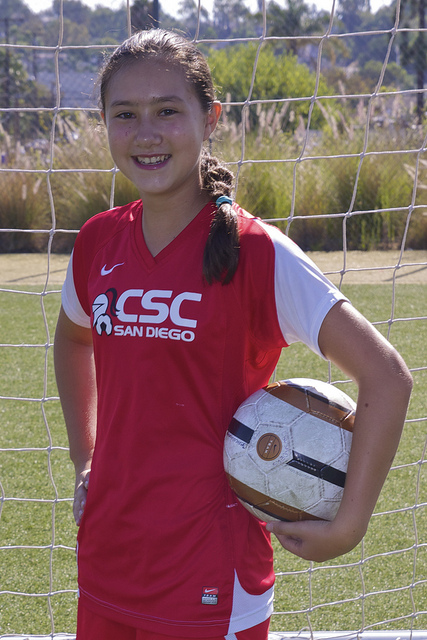Please transcribe the text in this image. CSC SAN DIEGO 